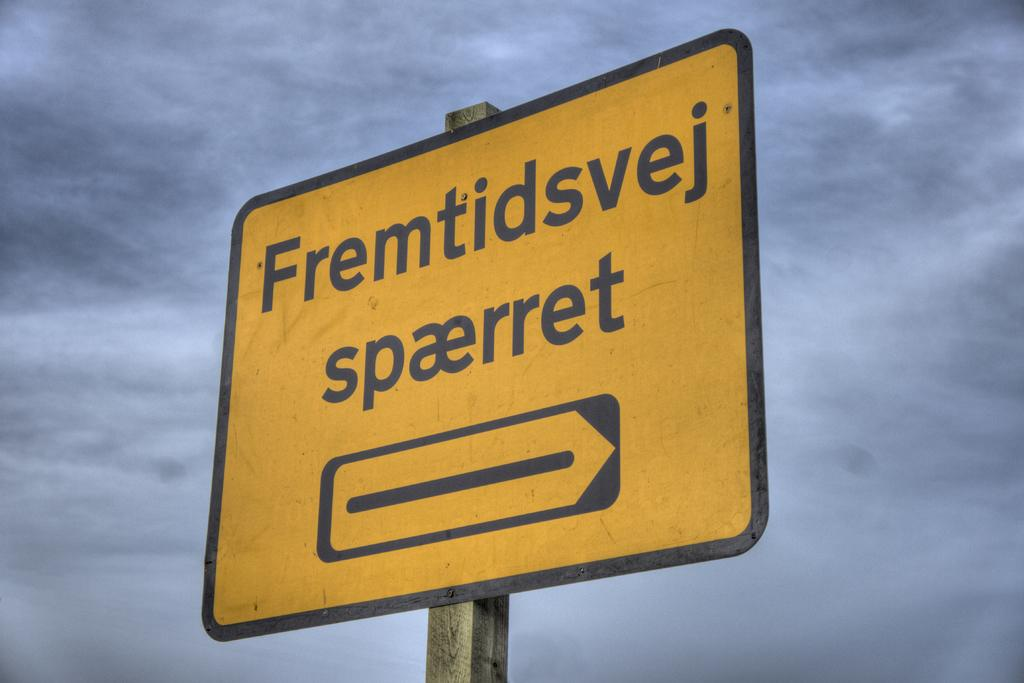What is the main object in the image? There is a direction board in the image. What can be seen in the background of the image? The sky is visible in the background of the image. How many nuts are hanging from the direction board in the image? There are no nuts present in the image; it only features a direction board and the sky in the background. 